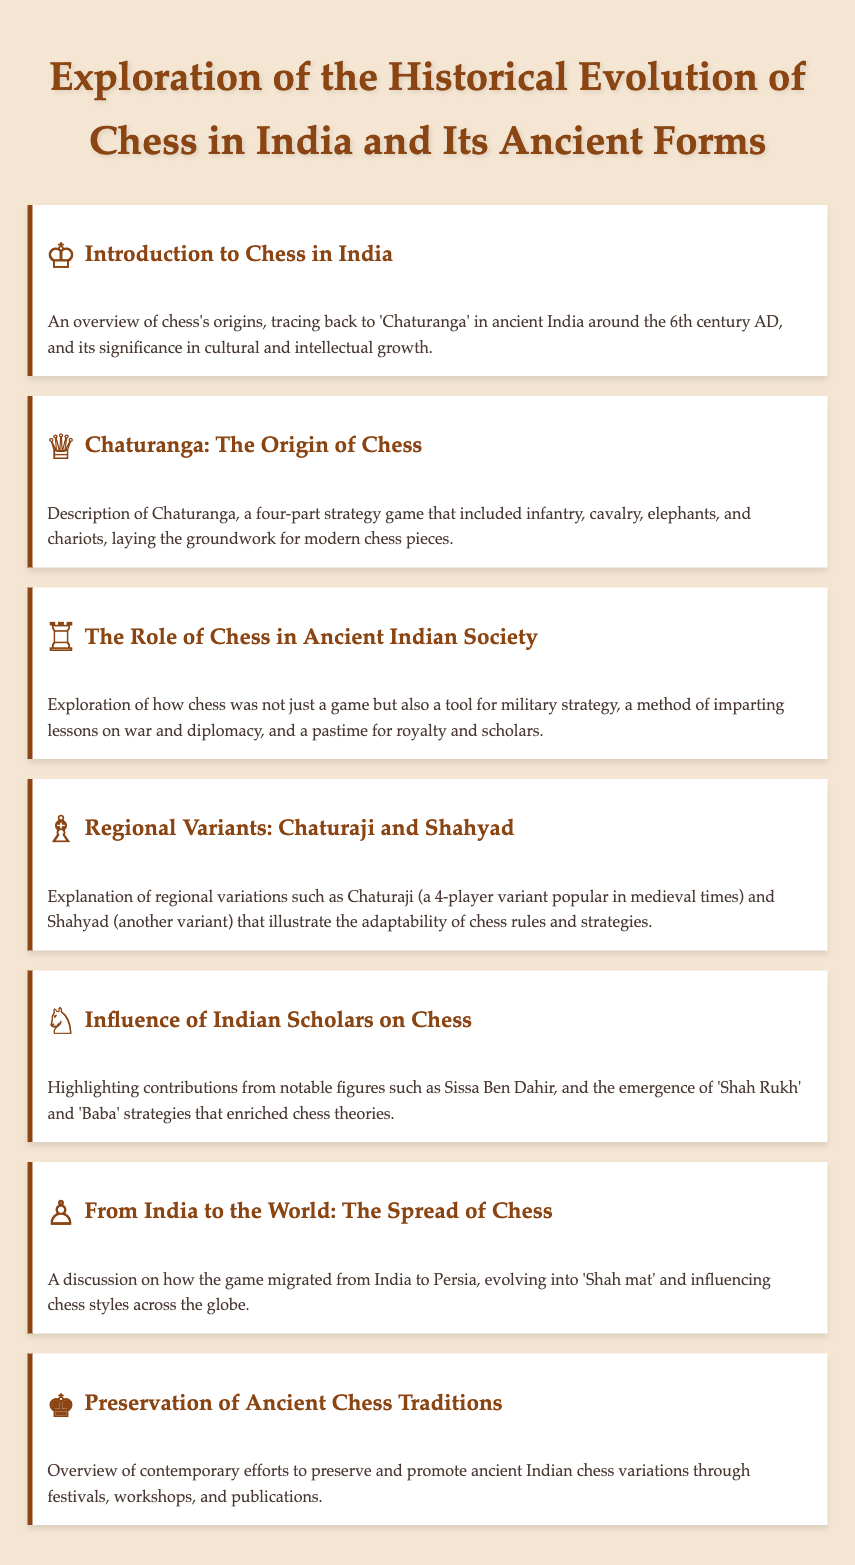What is the origin of chess in India? The document states that chess originated from 'Chaturanga' in ancient India around the 6th century AD.
Answer: 'Chaturanga' What four components were included in Chaturanga? The description of Chaturanga in the document mentions infantry, cavalry, elephants, and chariots as its components.
Answer: Infantry, cavalry, elephants, chariots Who contributed notably to Indian chess? The document highlights Sissa Ben Dahir as a notable figure in chess contributions.
Answer: Sissa Ben Dahir What was one role of chess in ancient Indian society? The document states that chess was a tool for military strategy in ancient society.
Answer: Military strategy What is a regional variant of chess mentioned in the document? The agenda item discusses Chaturaji as a regional variant of chess.
Answer: Chaturaji What phrase describes the evolution of chess from India to the world? The document refers to chess evolving into 'Shah mat' as it migrated from India to Persia.
Answer: 'Shah mat' How is the preservation of ancient chess traditions addressed? The document mentions contemporary efforts through festivals, workshops, and publications.
Answer: Festivals, workshops, publications 